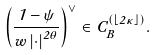<formula> <loc_0><loc_0><loc_500><loc_500>\left ( \frac { 1 - \psi } { w \left | \cdot \right | ^ { 2 \theta } } \right ) ^ { \vee } \in C _ { B } ^ { \left ( \left \lfloor 2 \kappa \right \rfloor \right ) } .</formula> 